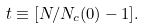<formula> <loc_0><loc_0><loc_500><loc_500>t \equiv [ N / N _ { c } ( 0 ) - 1 ] .</formula> 